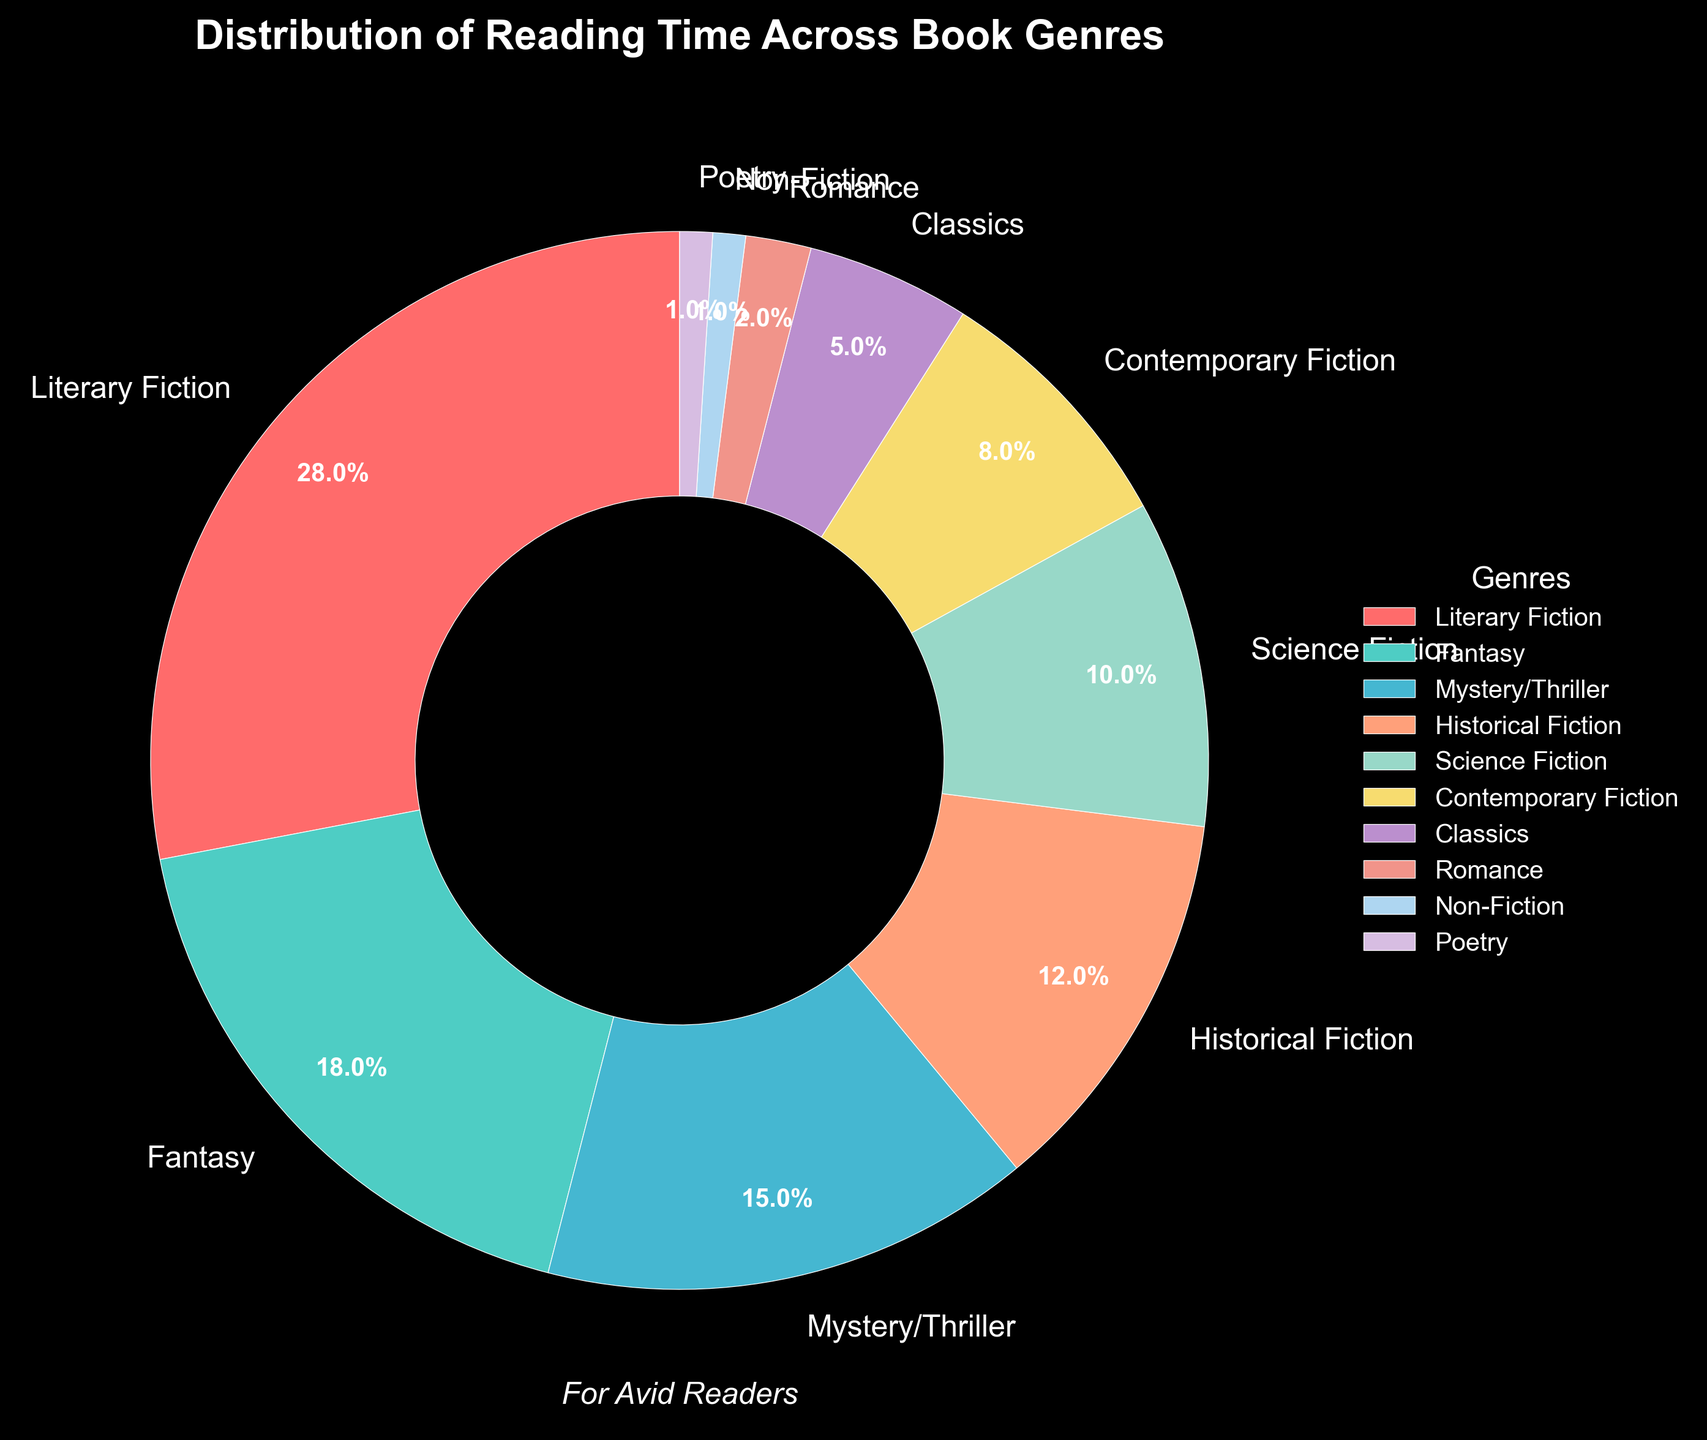Which genre takes up the largest percentage of reading time? The pie chart shows that Literary Fiction has the largest slice, labeled with 28%.
Answer: Literary Fiction Which two genres together account for the largest combined percentage of reading time? Literary Fiction accounts for 28% and Fantasy accounts for 18%. Adding them together gives 28% + 18% = 46%.
Answer: Literary Fiction and Fantasy How much more reading time is spent on Literary Fiction compared to Science Fiction? Literary Fiction is 28% and Science Fiction is 10%. Subtracting these gives 28% - 10% = 18%.
Answer: 18% Which genre has the smallest percentage of reading time allocated? The pie chart shows the smallest percentages are tied between Non-Fiction and Poetry, each labeled with 1%.
Answer: Non-Fiction and Poetry What's the overall reading time percentage allocated to fiction genres combined? Adding up Literary Fiction (28%), Fantasy (18%), Mystery/Thriller (15%), Historical Fiction (12%), Science Fiction (10%), Contemporary Fiction (8%), and Classics (5%) gives 28% + 18% + 15% + 12% + 10% + 8% + 5% = 96%.
Answer: 96% How does the reading time of Contemporary Fiction compare to Classics? Contemporary Fiction accounts for 8% and Classics for 5%. 8% - 5% = 3%, indicating more time is spent on Contemporary Fiction than Classics.
Answer: Contemporary Fiction has 3% more Which genre reads more than Mystery & Thriller but less than Literary Fiction? Fantasy accounts for 18%, which is more than Mystery/Thriller's 15% but less than Literary Fiction's 28%.
Answer: Fantasy What percentage of reading time is allocated to genres other than Literary Fiction, Fantasy, and Mystery/Thriller? Adding Literary Fiction (28%), Fantasy (18%), and Mystery/Thriller (15%) gives 28% + 18% + 15% = 61%. Subtracting this from 100% gives 100% - 61% = 39%.
Answer: 39% Is more time spent reading Historical Fiction or Science Fiction? The pie chart shows that Historical Fiction accounts for 12%, while Science Fiction accounts for 10%.
Answer: Historical Fiction What is the combined total of reading time allocated to the three least read genres? The three least read genres are Non-Fiction (1%), Poetry (1%), and Romance (2%). Adding them together gives 1% + 1% + 2% = 4%.
Answer: 4% 